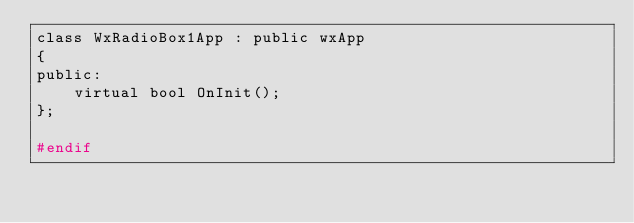Convert code to text. <code><loc_0><loc_0><loc_500><loc_500><_C_>class WxRadioBox1App : public wxApp
{
public:
    virtual bool OnInit();
};

#endif
</code> 